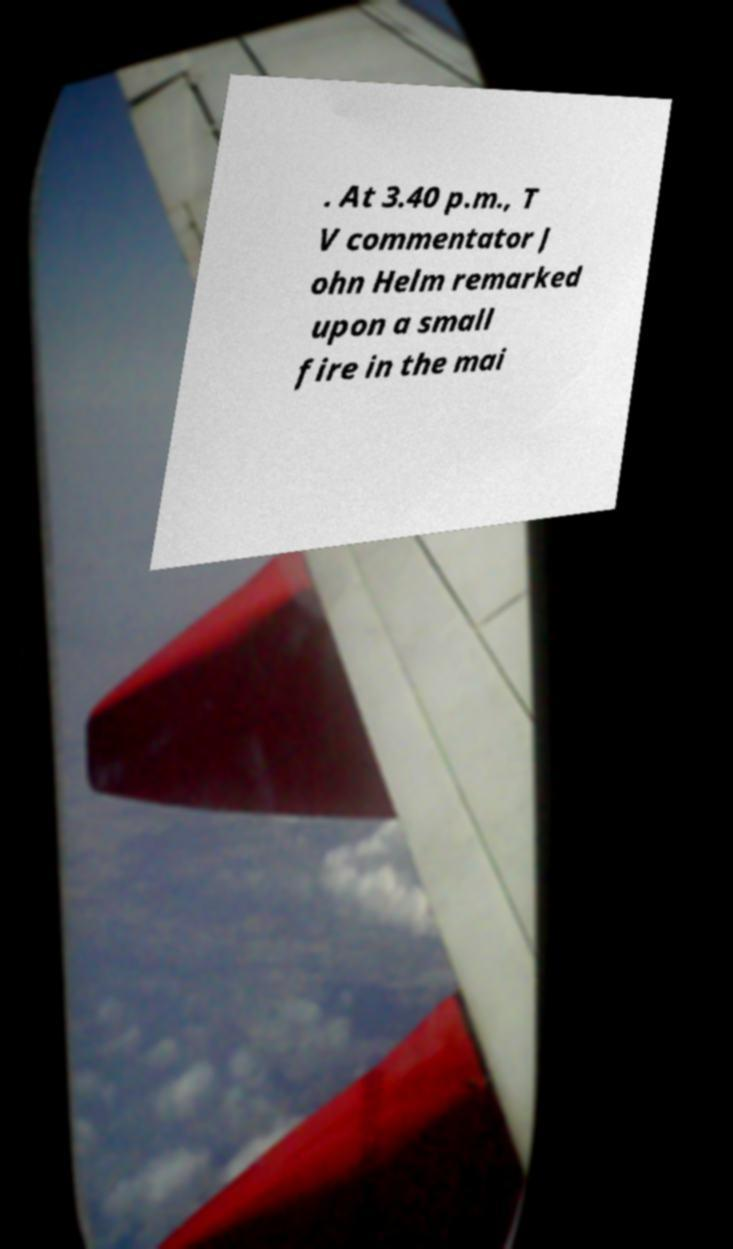Can you accurately transcribe the text from the provided image for me? . At 3.40 p.m., T V commentator J ohn Helm remarked upon a small fire in the mai 